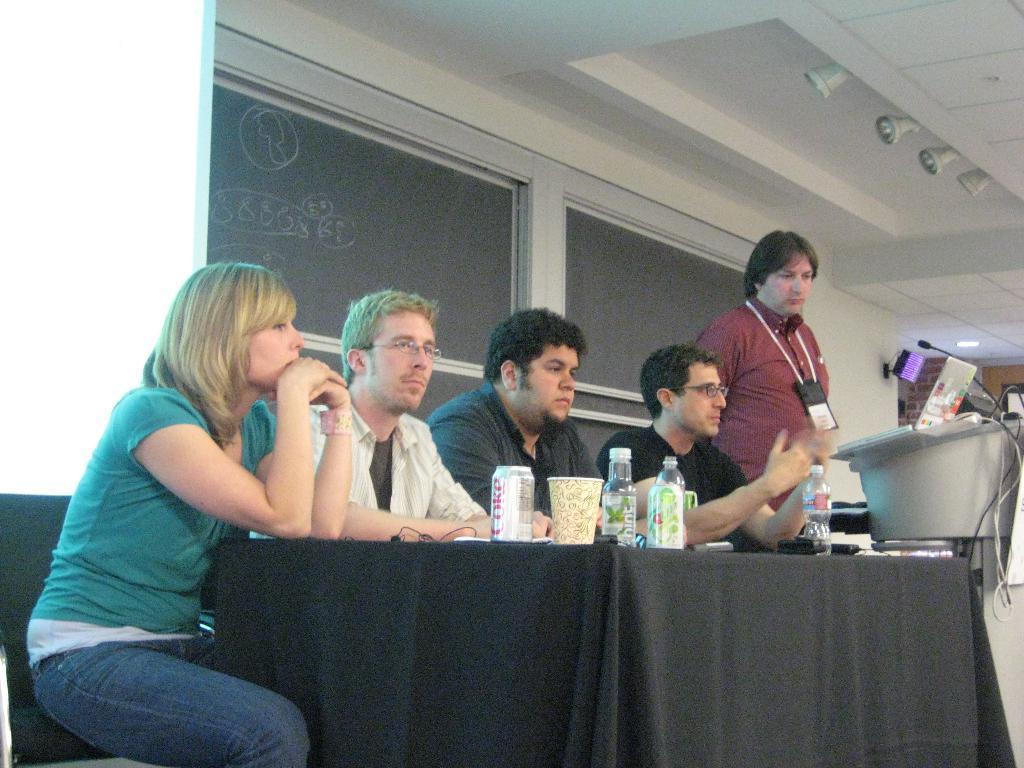In one or two sentences, can you explain what this image depicts? This image is taken inside the room. At the background there is a wall and windows. At the top of the image there is a ceiling with lights. In the middle of the image there is a table with cloth on it and there are few things on it. In this image there were five people, four men and one woman sitting on a chair. 